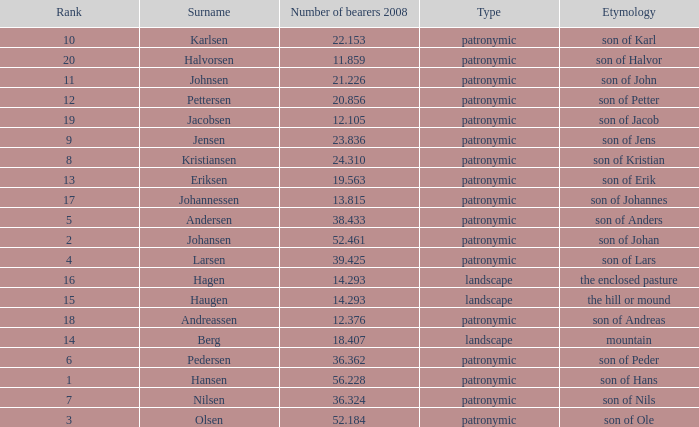What is the highest Number of Bearers 2008, when Surname is Hansen, and when Rank is less than 1? None. 